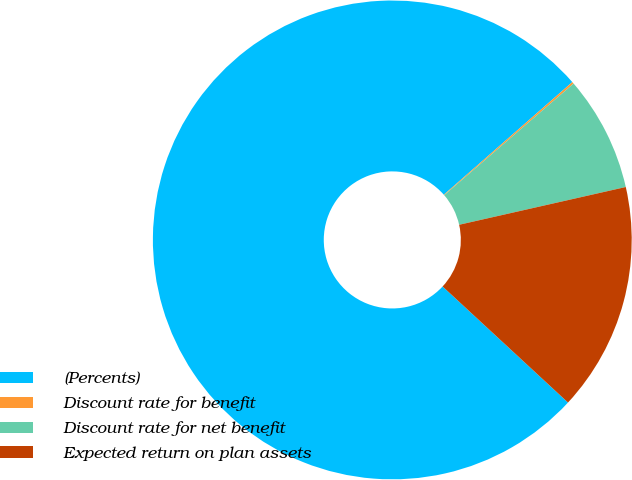Convert chart to OTSL. <chart><loc_0><loc_0><loc_500><loc_500><pie_chart><fcel>(Percents)<fcel>Discount rate for benefit<fcel>Discount rate for net benefit<fcel>Expected return on plan assets<nl><fcel>76.65%<fcel>0.13%<fcel>7.78%<fcel>15.43%<nl></chart> 